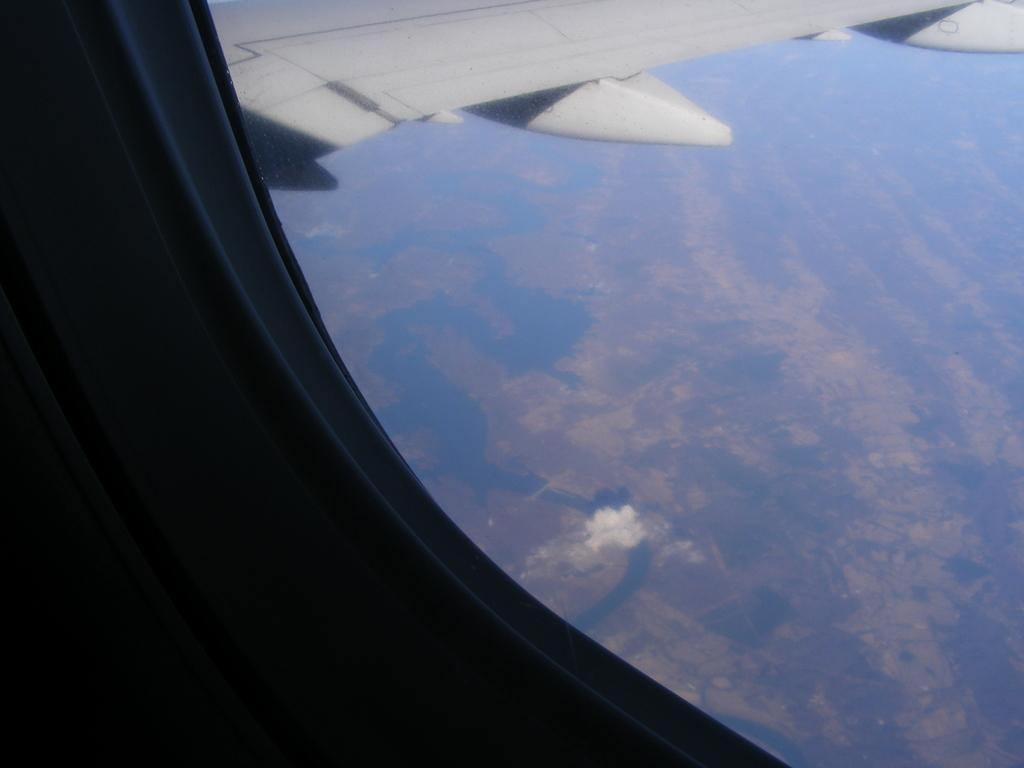What is the main subject of the image? The main subject of the image is an aeroplane window. What can be said about the color of the aeroplane window? The aeroplane window is white in color. How many eyes can be seen on the zebra in the image? There is no zebra present in the image, so it is not possible to determine the number of eyes. 